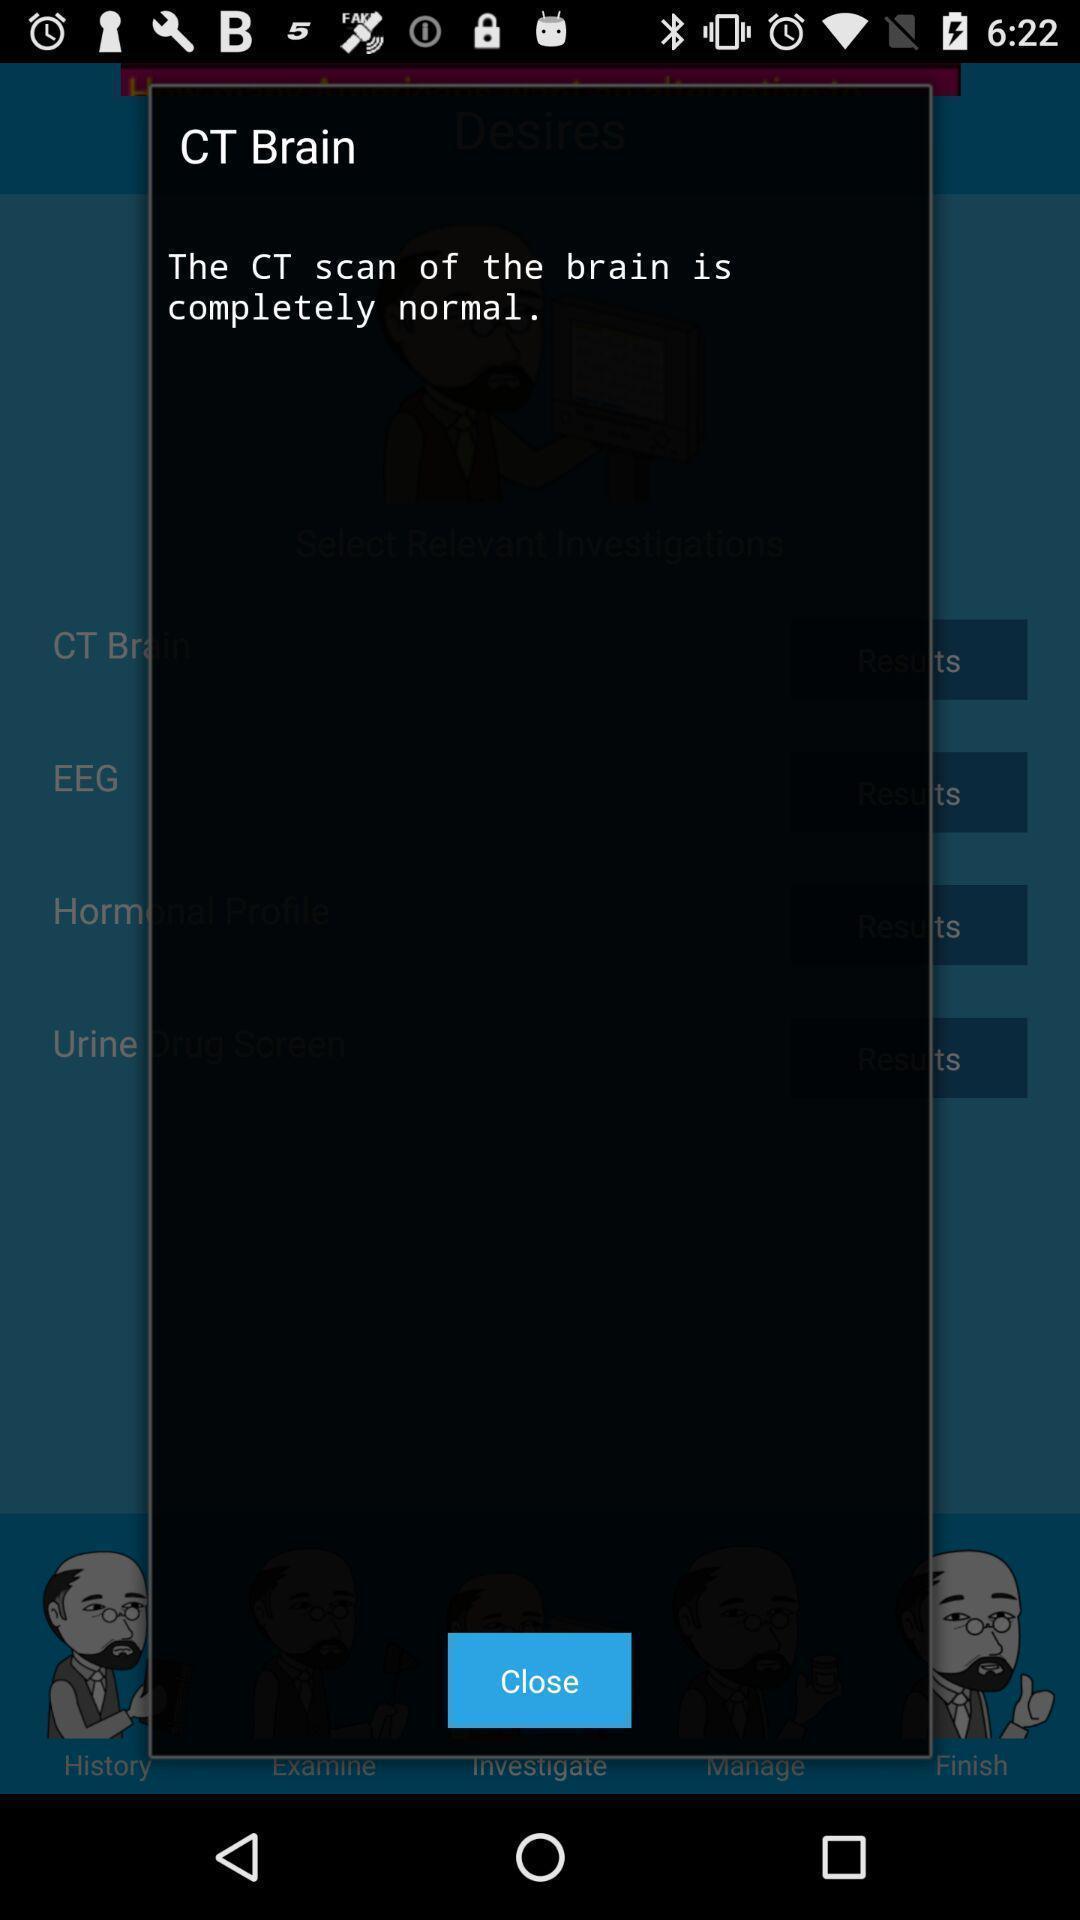Provide a textual representation of this image. Pop-up giving information about body scanning app. 